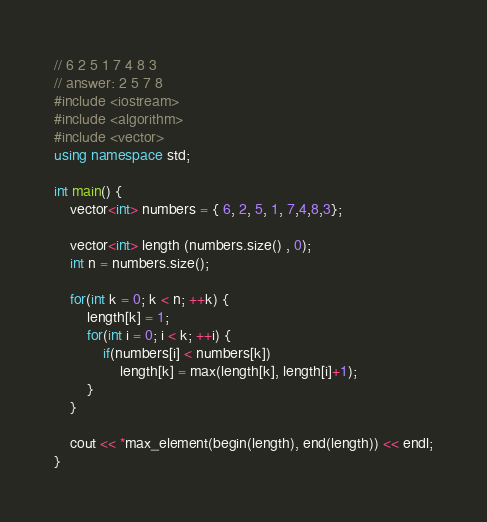<code> <loc_0><loc_0><loc_500><loc_500><_C++_>// 6 2 5 1 7 4 8 3
// answer: 2 5 7 8
#include <iostream>
#include <algorithm>
#include <vector>
using namespace std;

int main() {
    vector<int> numbers = { 6, 2, 5, 1, 7,4,8,3};

    vector<int> length (numbers.size() , 0);
    int n = numbers.size();

    for(int k = 0; k < n; ++k) {
        length[k] = 1;
        for(int i = 0; i < k; ++i) {
            if(numbers[i] < numbers[k])
                length[k] = max(length[k], length[i]+1);
        }
    }

    cout << *max_element(begin(length), end(length)) << endl;
}
</code> 